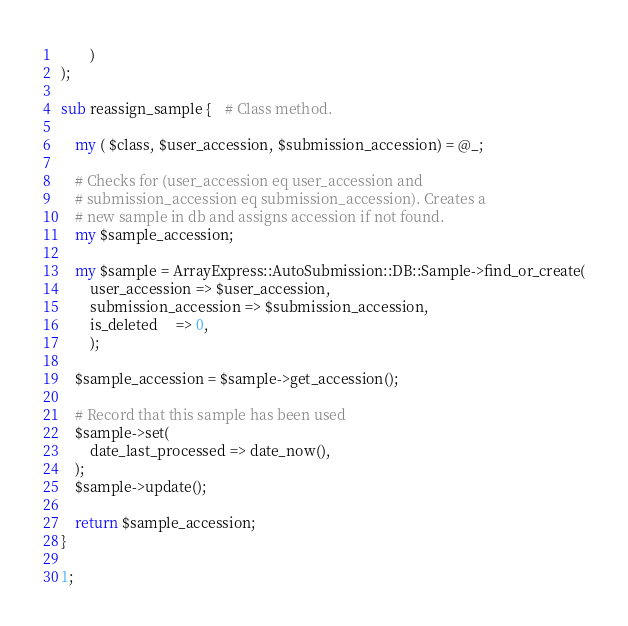<code> <loc_0><loc_0><loc_500><loc_500><_Perl_>        )
);

sub reassign_sample {    # Class method.

    my ( $class, $user_accession, $submission_accession) = @_;

    # Checks for (user_accession eq user_accession and 
    # submission_accession eq submission_accession). Creates a
    # new sample in db and assigns accession if not found.
    my $sample_accession;

	my $sample = ArrayExpress::AutoSubmission::DB::Sample->find_or_create(
	    user_accession => $user_accession,
		submission_accession => $submission_accession,
		is_deleted     => 0,
		);

	$sample_accession = $sample->get_accession();

    # Record that this sample has been used
	$sample->set(
	    date_last_processed => date_now(),
	);
	$sample->update();

    return $sample_accession;
}

1;
</code> 